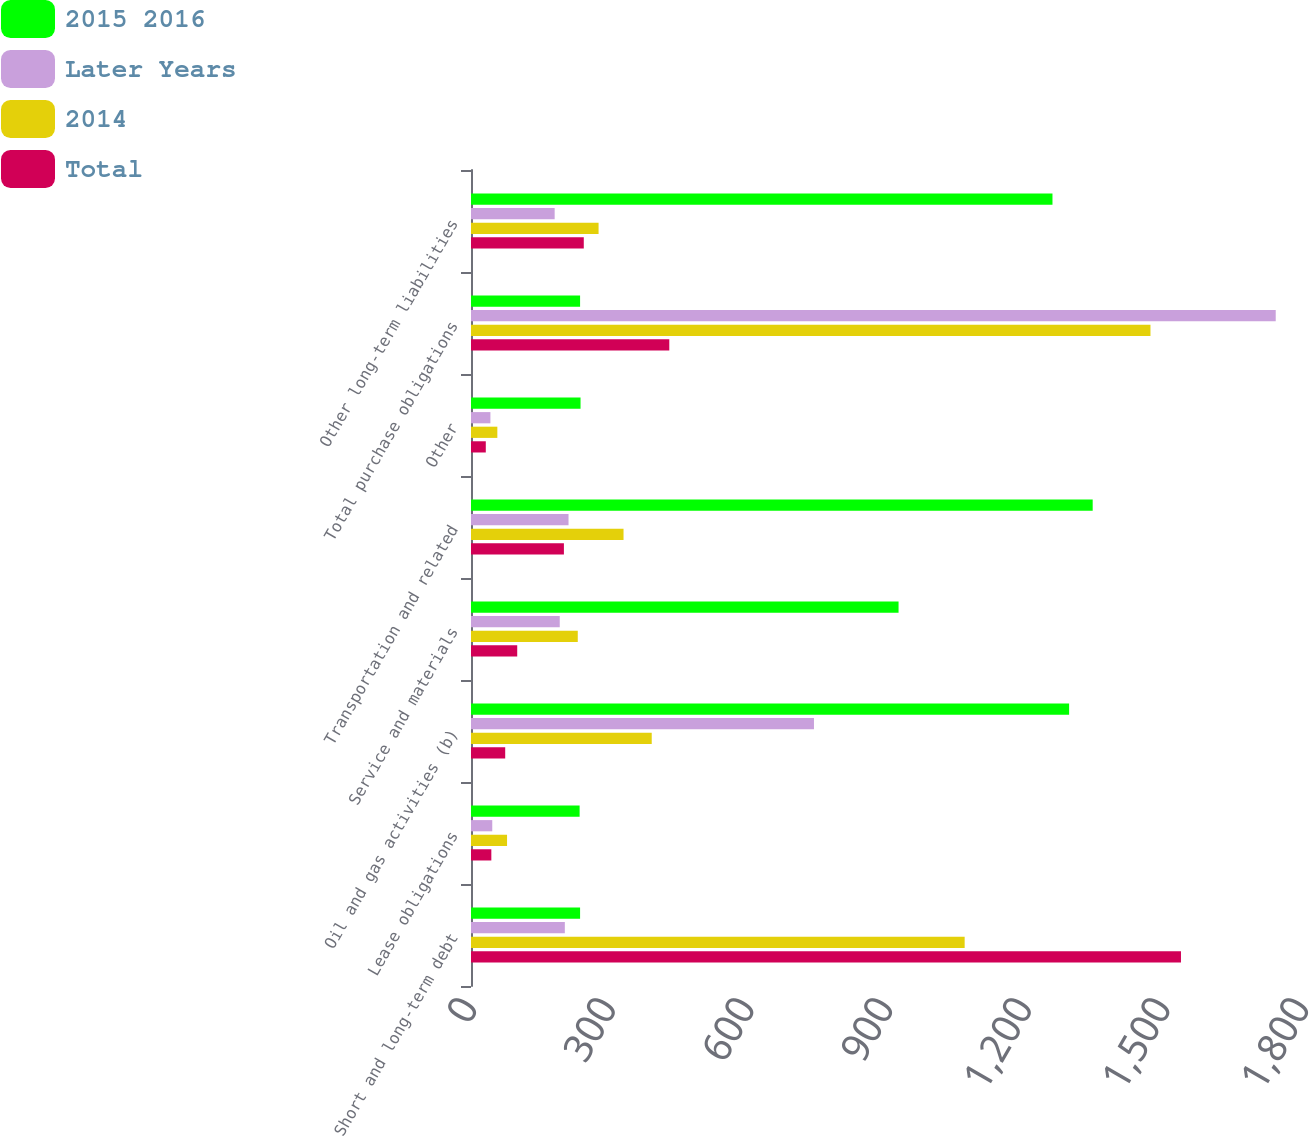<chart> <loc_0><loc_0><loc_500><loc_500><stacked_bar_chart><ecel><fcel>Short and long-term debt<fcel>Lease obligations<fcel>Oil and gas activities (b)<fcel>Service and materials<fcel>Transportation and related<fcel>Other<fcel>Total purchase obligations<fcel>Other long-term liabilities<nl><fcel>2015 2016<fcel>236<fcel>235<fcel>1294<fcel>925<fcel>1345<fcel>237<fcel>236<fcel>1258<nl><fcel>Later Years<fcel>203<fcel>46<fcel>742<fcel>192<fcel>211<fcel>42<fcel>1741<fcel>181<nl><fcel>2014<fcel>1068<fcel>78<fcel>391<fcel>231<fcel>330<fcel>57<fcel>1470<fcel>276<nl><fcel>Total<fcel>1536<fcel>44<fcel>74<fcel>100<fcel>201<fcel>32<fcel>429<fcel>244<nl></chart> 